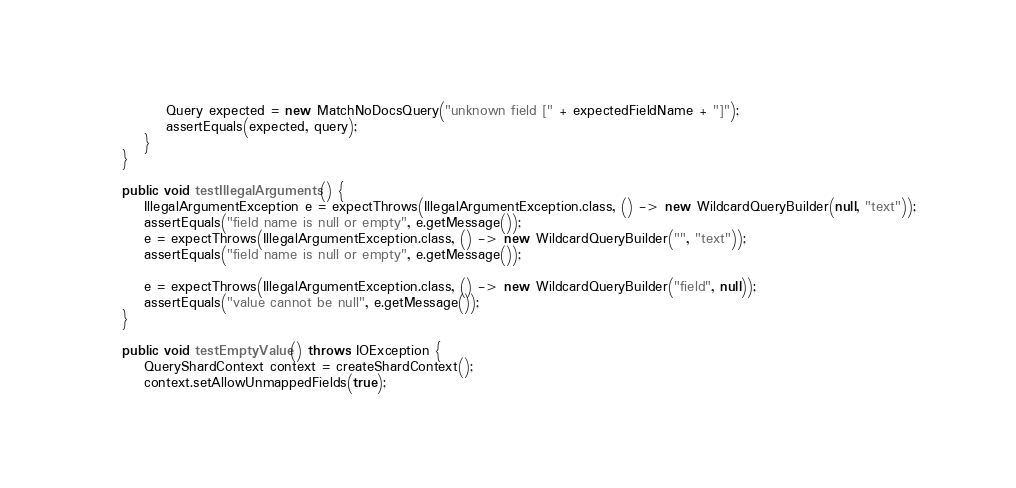<code> <loc_0><loc_0><loc_500><loc_500><_Java_>            Query expected = new MatchNoDocsQuery("unknown field [" + expectedFieldName + "]");
            assertEquals(expected, query);
        }
    }

    public void testIllegalArguments() {
        IllegalArgumentException e = expectThrows(IllegalArgumentException.class, () -> new WildcardQueryBuilder(null, "text"));
        assertEquals("field name is null or empty", e.getMessage());
        e = expectThrows(IllegalArgumentException.class, () -> new WildcardQueryBuilder("", "text"));
        assertEquals("field name is null or empty", e.getMessage());

        e = expectThrows(IllegalArgumentException.class, () -> new WildcardQueryBuilder("field", null));
        assertEquals("value cannot be null", e.getMessage());
    }

    public void testEmptyValue() throws IOException {
        QueryShardContext context = createShardContext();
        context.setAllowUnmappedFields(true);</code> 